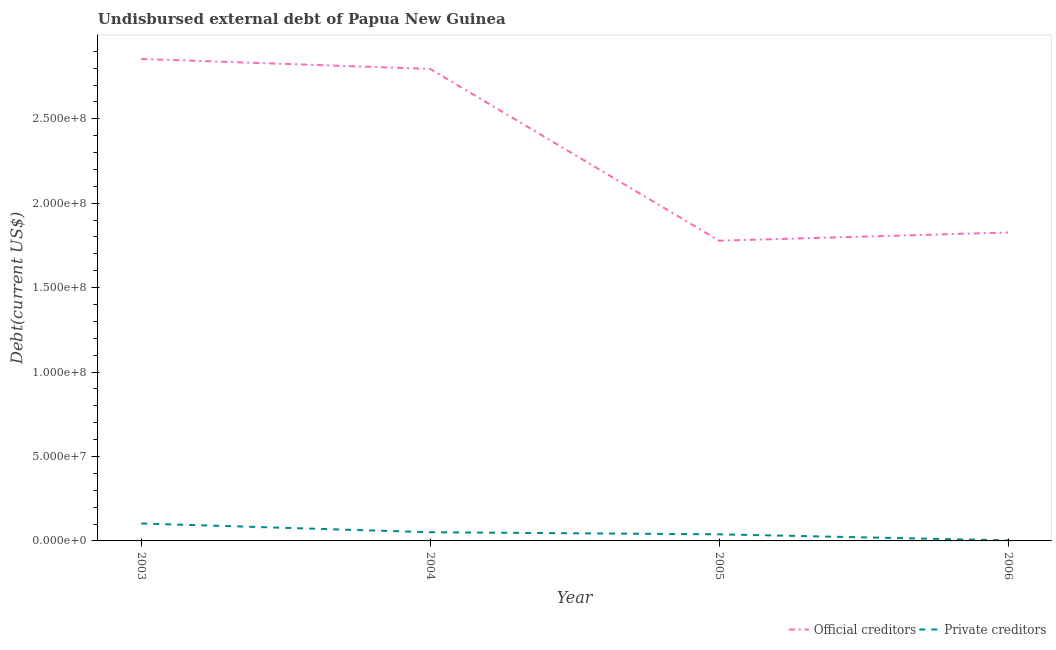Does the line corresponding to undisbursed external debt of private creditors intersect with the line corresponding to undisbursed external debt of official creditors?
Make the answer very short. No. Is the number of lines equal to the number of legend labels?
Keep it short and to the point. Yes. What is the undisbursed external debt of private creditors in 2006?
Your response must be concise. 3.19e+05. Across all years, what is the maximum undisbursed external debt of official creditors?
Your response must be concise. 2.85e+08. Across all years, what is the minimum undisbursed external debt of private creditors?
Your answer should be very brief. 3.19e+05. What is the total undisbursed external debt of private creditors in the graph?
Provide a short and direct response. 1.97e+07. What is the difference between the undisbursed external debt of official creditors in 2003 and that in 2005?
Your response must be concise. 1.08e+08. What is the difference between the undisbursed external debt of private creditors in 2005 and the undisbursed external debt of official creditors in 2006?
Your response must be concise. -1.79e+08. What is the average undisbursed external debt of private creditors per year?
Give a very brief answer. 4.93e+06. In the year 2006, what is the difference between the undisbursed external debt of official creditors and undisbursed external debt of private creditors?
Provide a short and direct response. 1.82e+08. What is the ratio of the undisbursed external debt of private creditors in 2004 to that in 2005?
Ensure brevity in your answer.  1.32. What is the difference between the highest and the second highest undisbursed external debt of private creditors?
Ensure brevity in your answer.  5.18e+06. What is the difference between the highest and the lowest undisbursed external debt of private creditors?
Provide a succinct answer. 1.00e+07. In how many years, is the undisbursed external debt of private creditors greater than the average undisbursed external debt of private creditors taken over all years?
Give a very brief answer. 2. How many lines are there?
Give a very brief answer. 2. How many years are there in the graph?
Provide a succinct answer. 4. Are the values on the major ticks of Y-axis written in scientific E-notation?
Your answer should be compact. Yes. Does the graph contain any zero values?
Your answer should be very brief. No. What is the title of the graph?
Your answer should be very brief. Undisbursed external debt of Papua New Guinea. What is the label or title of the X-axis?
Give a very brief answer. Year. What is the label or title of the Y-axis?
Keep it short and to the point. Debt(current US$). What is the Debt(current US$) in Official creditors in 2003?
Give a very brief answer. 2.85e+08. What is the Debt(current US$) in Private creditors in 2003?
Your answer should be compact. 1.03e+07. What is the Debt(current US$) of Official creditors in 2004?
Offer a terse response. 2.80e+08. What is the Debt(current US$) of Private creditors in 2004?
Provide a succinct answer. 5.15e+06. What is the Debt(current US$) of Official creditors in 2005?
Give a very brief answer. 1.78e+08. What is the Debt(current US$) in Private creditors in 2005?
Ensure brevity in your answer.  3.91e+06. What is the Debt(current US$) in Official creditors in 2006?
Your answer should be compact. 1.83e+08. What is the Debt(current US$) of Private creditors in 2006?
Your answer should be very brief. 3.19e+05. Across all years, what is the maximum Debt(current US$) of Official creditors?
Your answer should be compact. 2.85e+08. Across all years, what is the maximum Debt(current US$) of Private creditors?
Offer a terse response. 1.03e+07. Across all years, what is the minimum Debt(current US$) of Official creditors?
Provide a succinct answer. 1.78e+08. Across all years, what is the minimum Debt(current US$) of Private creditors?
Ensure brevity in your answer.  3.19e+05. What is the total Debt(current US$) of Official creditors in the graph?
Make the answer very short. 9.25e+08. What is the total Debt(current US$) in Private creditors in the graph?
Your response must be concise. 1.97e+07. What is the difference between the Debt(current US$) of Official creditors in 2003 and that in 2004?
Your response must be concise. 5.90e+06. What is the difference between the Debt(current US$) of Private creditors in 2003 and that in 2004?
Your answer should be very brief. 5.18e+06. What is the difference between the Debt(current US$) in Official creditors in 2003 and that in 2005?
Provide a succinct answer. 1.08e+08. What is the difference between the Debt(current US$) in Private creditors in 2003 and that in 2005?
Offer a very short reply. 6.42e+06. What is the difference between the Debt(current US$) of Official creditors in 2003 and that in 2006?
Provide a succinct answer. 1.03e+08. What is the difference between the Debt(current US$) of Private creditors in 2003 and that in 2006?
Give a very brief answer. 1.00e+07. What is the difference between the Debt(current US$) in Official creditors in 2004 and that in 2005?
Your response must be concise. 1.02e+08. What is the difference between the Debt(current US$) in Private creditors in 2004 and that in 2005?
Keep it short and to the point. 1.24e+06. What is the difference between the Debt(current US$) of Official creditors in 2004 and that in 2006?
Offer a terse response. 9.69e+07. What is the difference between the Debt(current US$) of Private creditors in 2004 and that in 2006?
Offer a terse response. 4.83e+06. What is the difference between the Debt(current US$) in Official creditors in 2005 and that in 2006?
Ensure brevity in your answer.  -4.86e+06. What is the difference between the Debt(current US$) in Private creditors in 2005 and that in 2006?
Ensure brevity in your answer.  3.59e+06. What is the difference between the Debt(current US$) in Official creditors in 2003 and the Debt(current US$) in Private creditors in 2004?
Make the answer very short. 2.80e+08. What is the difference between the Debt(current US$) of Official creditors in 2003 and the Debt(current US$) of Private creditors in 2005?
Give a very brief answer. 2.82e+08. What is the difference between the Debt(current US$) in Official creditors in 2003 and the Debt(current US$) in Private creditors in 2006?
Give a very brief answer. 2.85e+08. What is the difference between the Debt(current US$) in Official creditors in 2004 and the Debt(current US$) in Private creditors in 2005?
Ensure brevity in your answer.  2.76e+08. What is the difference between the Debt(current US$) of Official creditors in 2004 and the Debt(current US$) of Private creditors in 2006?
Ensure brevity in your answer.  2.79e+08. What is the difference between the Debt(current US$) of Official creditors in 2005 and the Debt(current US$) of Private creditors in 2006?
Give a very brief answer. 1.77e+08. What is the average Debt(current US$) of Official creditors per year?
Your answer should be compact. 2.31e+08. What is the average Debt(current US$) of Private creditors per year?
Ensure brevity in your answer.  4.93e+06. In the year 2003, what is the difference between the Debt(current US$) in Official creditors and Debt(current US$) in Private creditors?
Your answer should be compact. 2.75e+08. In the year 2004, what is the difference between the Debt(current US$) in Official creditors and Debt(current US$) in Private creditors?
Your answer should be compact. 2.74e+08. In the year 2005, what is the difference between the Debt(current US$) in Official creditors and Debt(current US$) in Private creditors?
Offer a very short reply. 1.74e+08. In the year 2006, what is the difference between the Debt(current US$) of Official creditors and Debt(current US$) of Private creditors?
Ensure brevity in your answer.  1.82e+08. What is the ratio of the Debt(current US$) of Official creditors in 2003 to that in 2004?
Provide a short and direct response. 1.02. What is the ratio of the Debt(current US$) in Private creditors in 2003 to that in 2004?
Offer a terse response. 2.01. What is the ratio of the Debt(current US$) of Official creditors in 2003 to that in 2005?
Give a very brief answer. 1.61. What is the ratio of the Debt(current US$) in Private creditors in 2003 to that in 2005?
Ensure brevity in your answer.  2.64. What is the ratio of the Debt(current US$) of Official creditors in 2003 to that in 2006?
Make the answer very short. 1.56. What is the ratio of the Debt(current US$) of Private creditors in 2003 to that in 2006?
Provide a succinct answer. 32.37. What is the ratio of the Debt(current US$) of Official creditors in 2004 to that in 2005?
Provide a short and direct response. 1.57. What is the ratio of the Debt(current US$) of Private creditors in 2004 to that in 2005?
Give a very brief answer. 1.32. What is the ratio of the Debt(current US$) in Official creditors in 2004 to that in 2006?
Your response must be concise. 1.53. What is the ratio of the Debt(current US$) of Private creditors in 2004 to that in 2006?
Your answer should be very brief. 16.14. What is the ratio of the Debt(current US$) in Official creditors in 2005 to that in 2006?
Keep it short and to the point. 0.97. What is the ratio of the Debt(current US$) in Private creditors in 2005 to that in 2006?
Provide a short and direct response. 12.25. What is the difference between the highest and the second highest Debt(current US$) of Official creditors?
Offer a very short reply. 5.90e+06. What is the difference between the highest and the second highest Debt(current US$) in Private creditors?
Keep it short and to the point. 5.18e+06. What is the difference between the highest and the lowest Debt(current US$) in Official creditors?
Provide a succinct answer. 1.08e+08. What is the difference between the highest and the lowest Debt(current US$) of Private creditors?
Keep it short and to the point. 1.00e+07. 